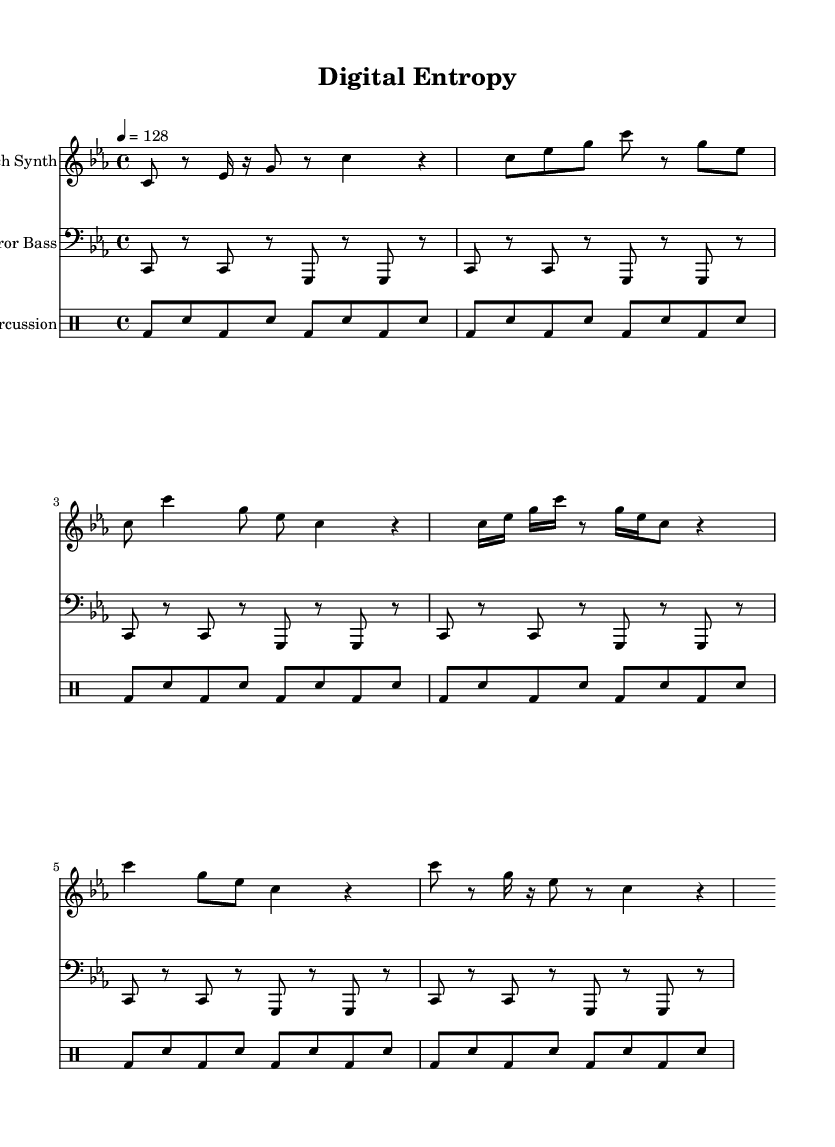What is the key signature of this music? The key signature is C minor, which has three flats: B♭, E♭, and A♭.
Answer: C minor What is the time signature of this piece? The time signature shown at the beginning of the score is 4/4, indicating four beats per measure and a quarter note gets one beat.
Answer: 4/4 What is the tempo marking given for the piece? The tempo marking is indicated as "4 = 128," meaning there are 128 beats per minute.
Answer: 128 How many measures are in the verse section? By counting the measures in the verse section of the piece, we see it consists of 4 measures as laid out in the sheet music.
Answer: 4 What instruments are used in this composition? The composition features a glitch synth, an error bass, and noise percussion, each specified at the beginning of their respective staves.
Answer: Glitch Synth, Error Bass, Noise Percussion What unique musical elements are present in the bridge section? The bridge includes a combination of sixteenth notes and rests which create a contrasting rhythm, showcasing the piece's glitch-inspired style.
Answer: Sixteenth notes and rests What is the primary function of the noise percussion in this piece? The noise percussion primarily serves to provide a rhythmic foundation, enhancing the experimental and glitch aesthetic by employing a repetitive bass and snare pattern.
Answer: Rhythmic foundation 